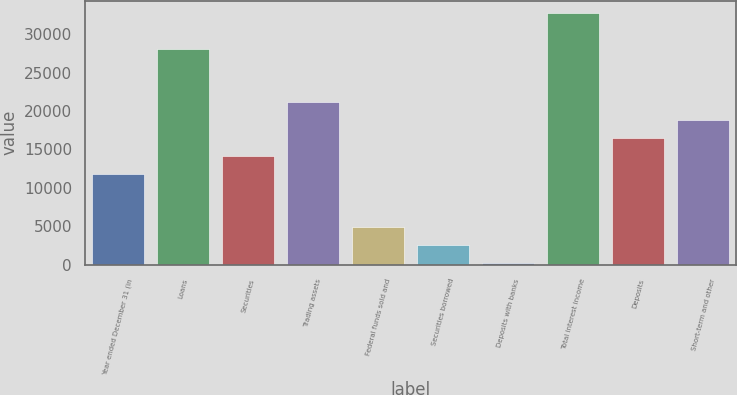<chart> <loc_0><loc_0><loc_500><loc_500><bar_chart><fcel>Year ended December 31 (in<fcel>Loans<fcel>Securities<fcel>Trading assets<fcel>Federal funds sold and<fcel>Securities borrowed<fcel>Deposits with banks<fcel>Total interest income<fcel>Deposits<fcel>Short-term and other<nl><fcel>11829<fcel>28090<fcel>14152<fcel>21121<fcel>4860<fcel>2537<fcel>214<fcel>32736<fcel>16475<fcel>18798<nl></chart> 